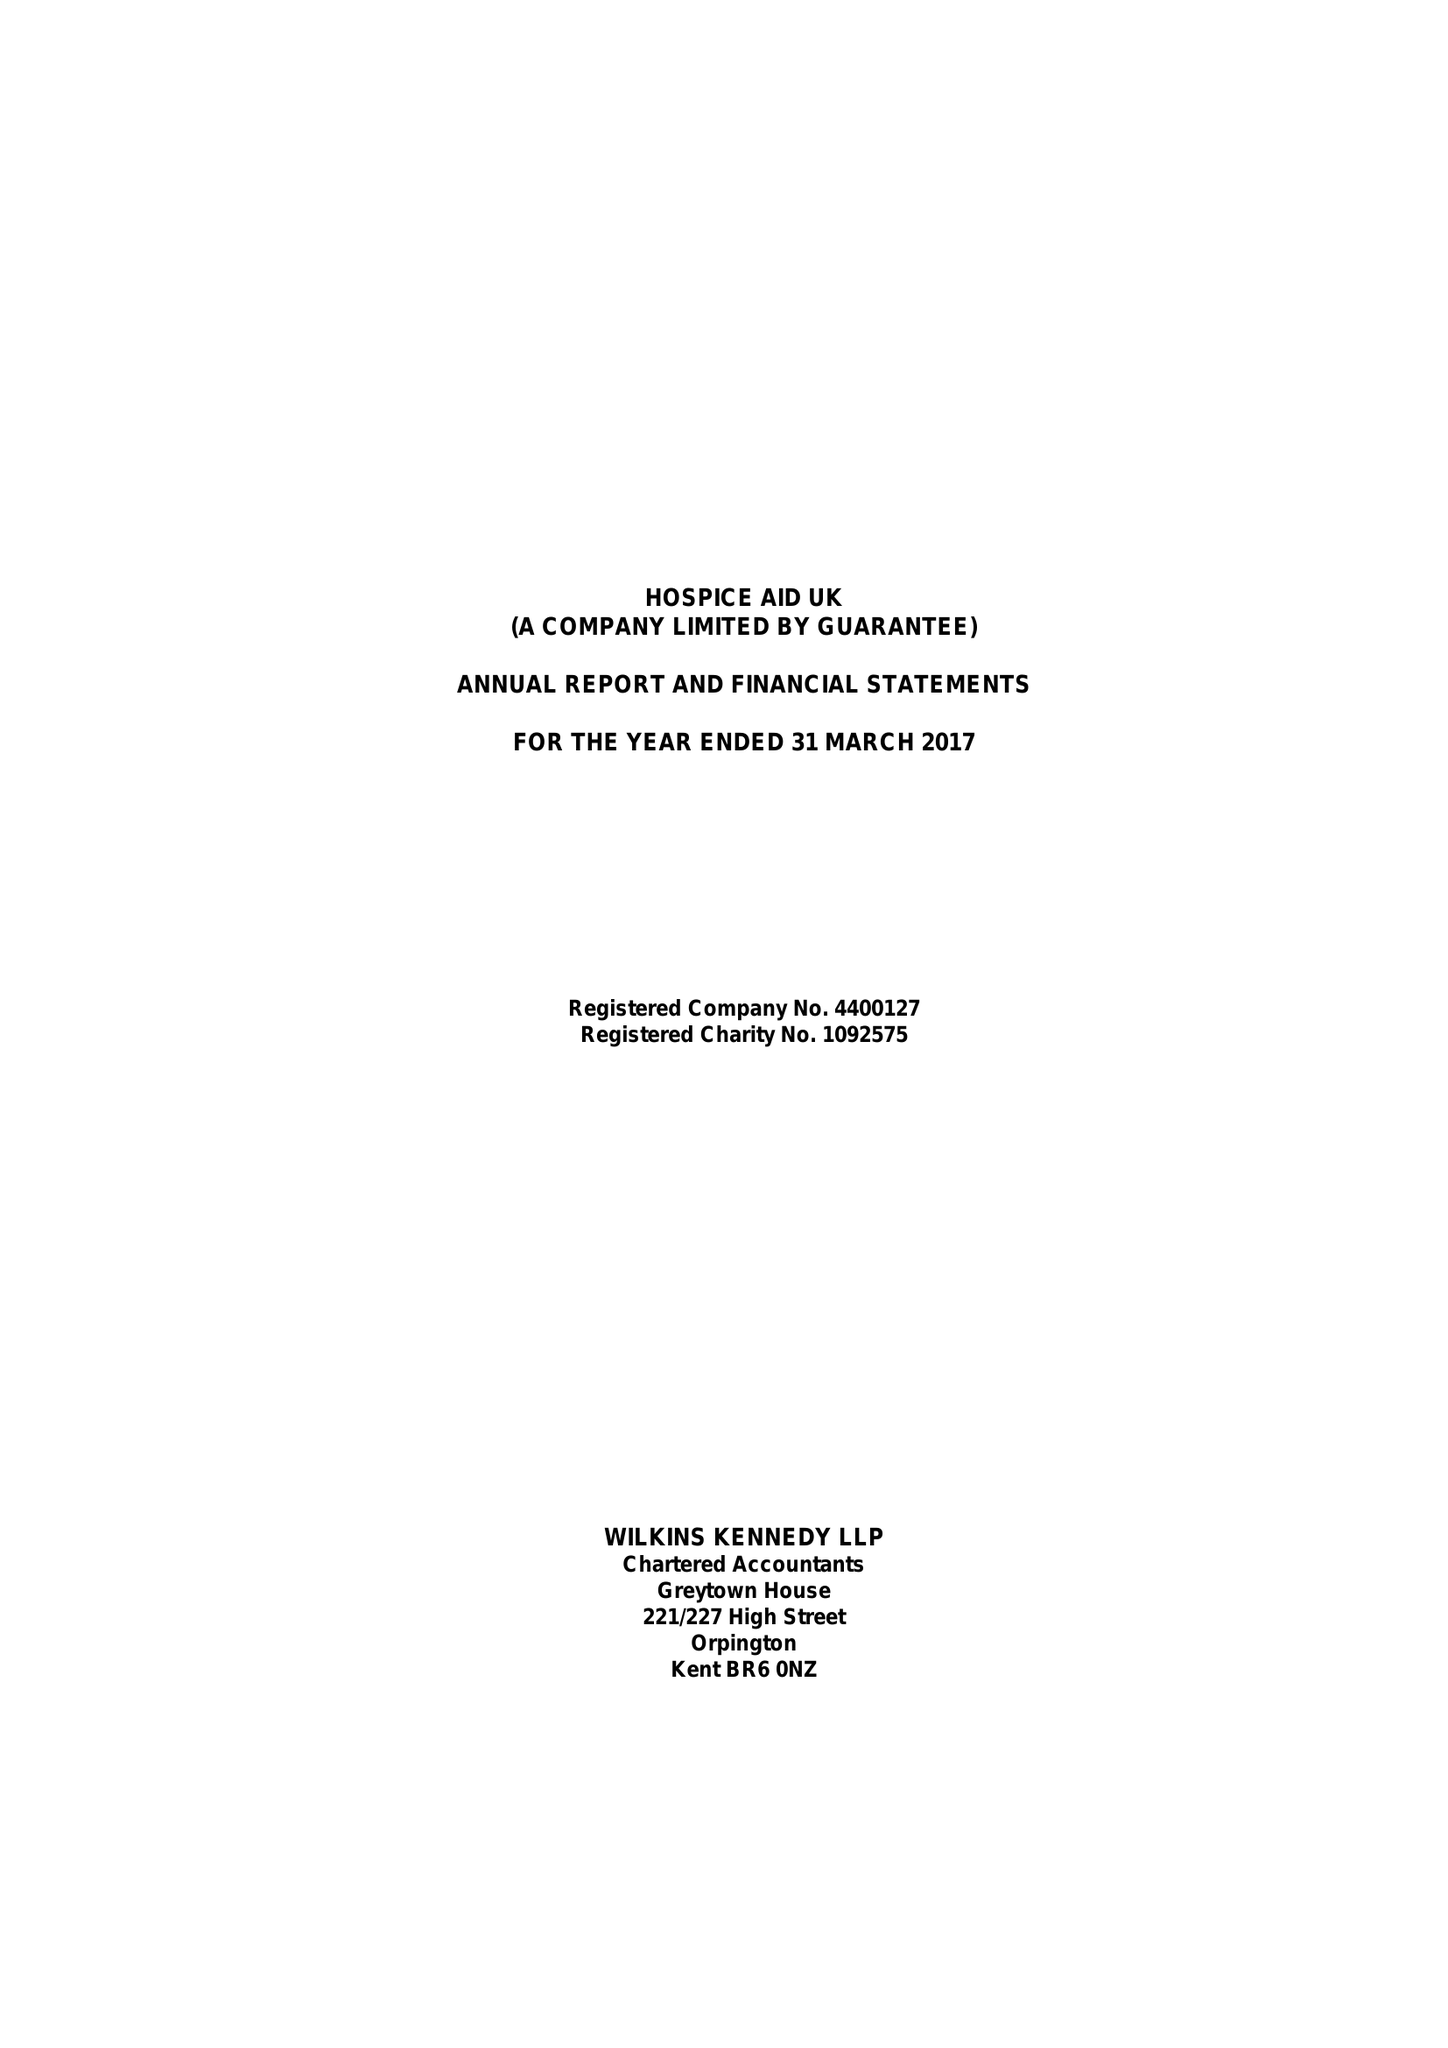What is the value for the address__post_town?
Answer the question using a single word or phrase. CRAWLEY 